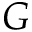<formula> <loc_0><loc_0><loc_500><loc_500>G</formula> 